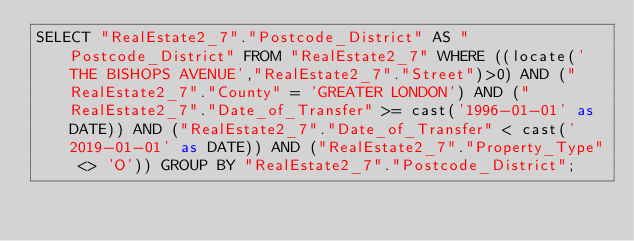<code> <loc_0><loc_0><loc_500><loc_500><_SQL_>SELECT "RealEstate2_7"."Postcode_District" AS "Postcode_District" FROM "RealEstate2_7" WHERE ((locate('THE BISHOPS AVENUE',"RealEstate2_7"."Street")>0) AND ("RealEstate2_7"."County" = 'GREATER LONDON') AND ("RealEstate2_7"."Date_of_Transfer" >= cast('1996-01-01' as DATE)) AND ("RealEstate2_7"."Date_of_Transfer" < cast('2019-01-01' as DATE)) AND ("RealEstate2_7"."Property_Type" <> 'O')) GROUP BY "RealEstate2_7"."Postcode_District";
</code> 